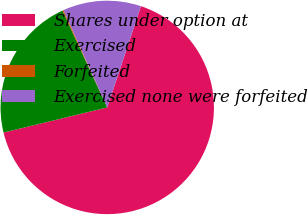<chart> <loc_0><loc_0><loc_500><loc_500><pie_chart><fcel>Shares under option at<fcel>Exercised<fcel>Forfeited<fcel>Exercised none were forfeited<nl><fcel>66.11%<fcel>21.89%<fcel>0.17%<fcel>11.84%<nl></chart> 